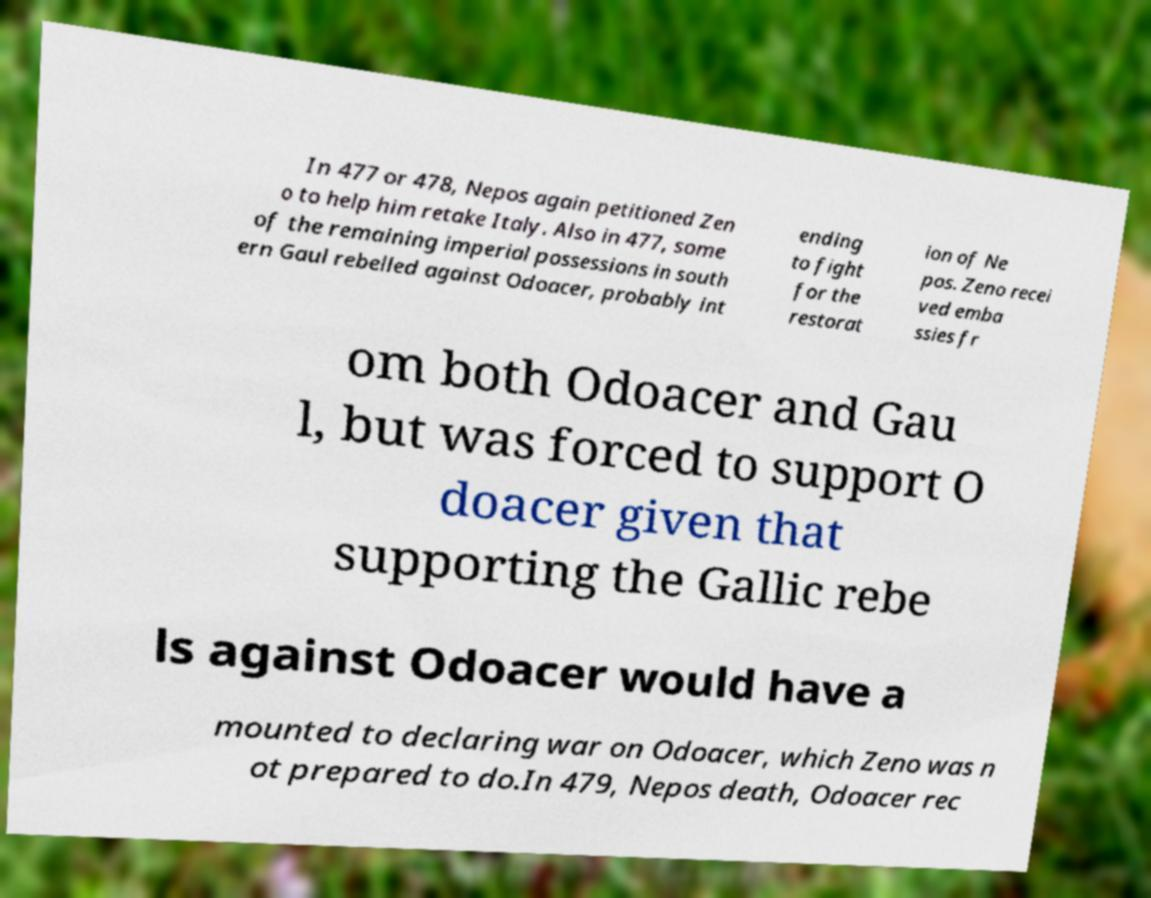I need the written content from this picture converted into text. Can you do that? In 477 or 478, Nepos again petitioned Zen o to help him retake Italy. Also in 477, some of the remaining imperial possessions in south ern Gaul rebelled against Odoacer, probably int ending to fight for the restorat ion of Ne pos. Zeno recei ved emba ssies fr om both Odoacer and Gau l, but was forced to support O doacer given that supporting the Gallic rebe ls against Odoacer would have a mounted to declaring war on Odoacer, which Zeno was n ot prepared to do.In 479, Nepos death, Odoacer rec 